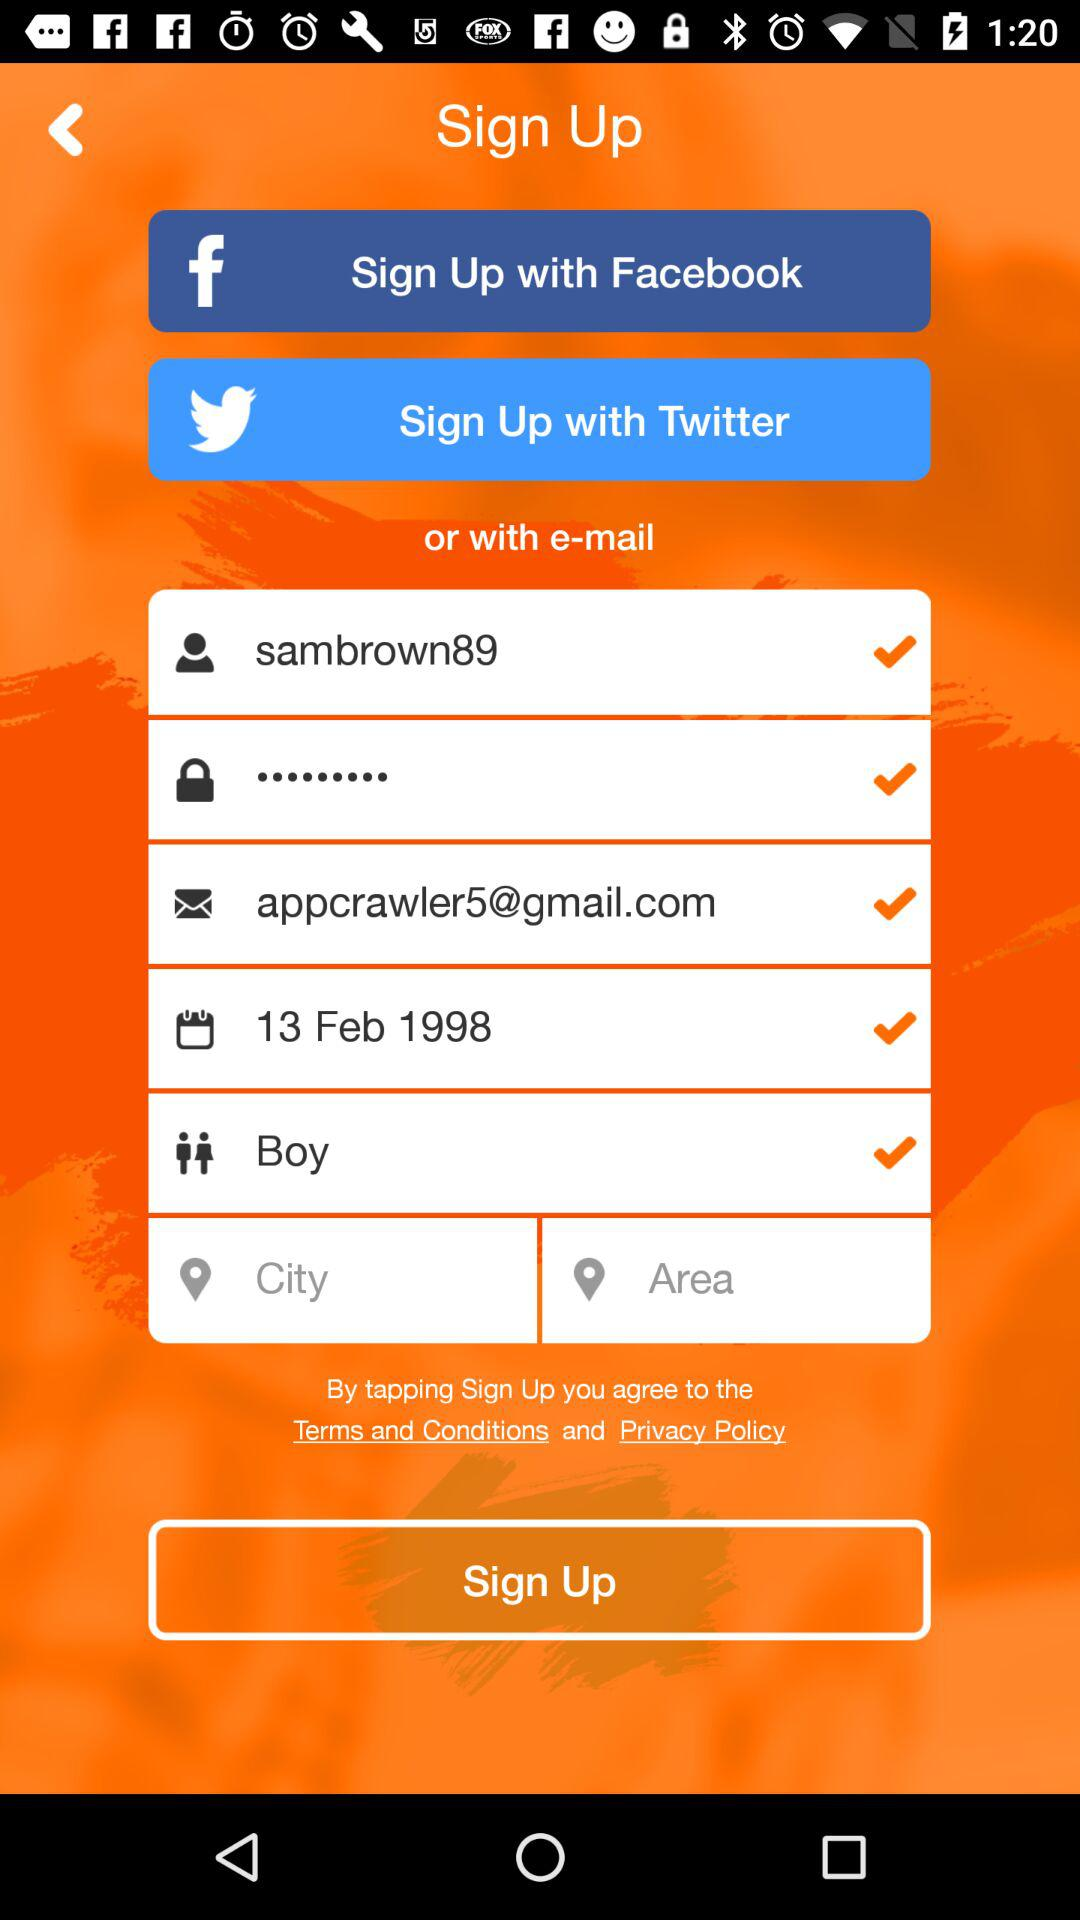What is the email address entered for sign up? The entered email address is appcrawler5@gmail.com. 